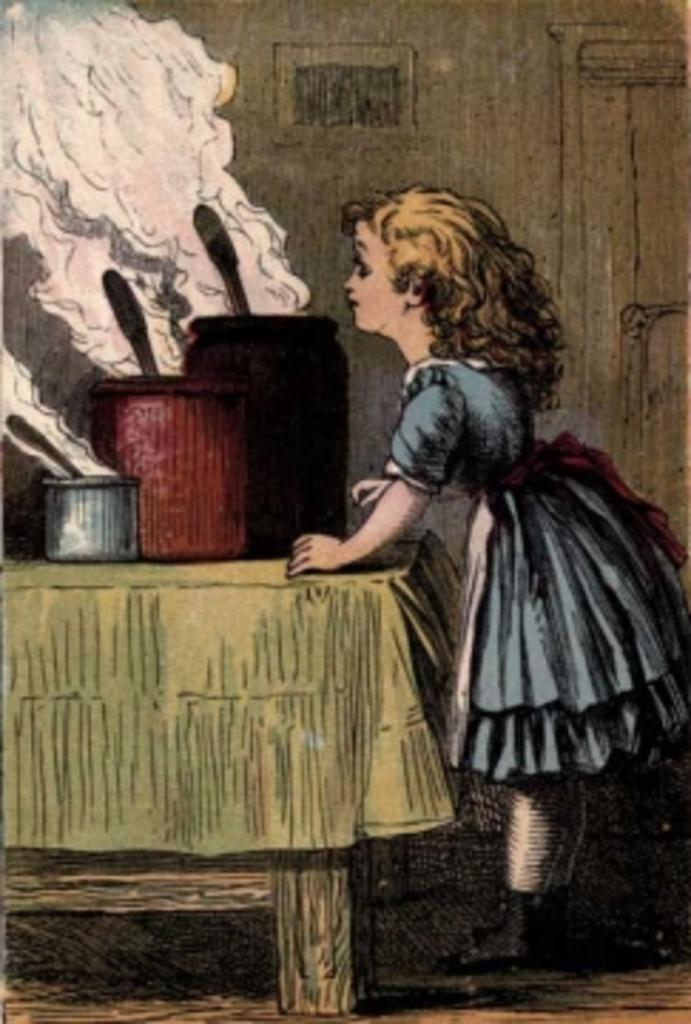What type of image is being described? The image contains animation. Can you describe the scene in the image? There is a girl standing beside a table. What is on the table in the image? There are objects on the table. How many sisters does the girl have in the image? There is no mention of sisters in the image, as it only features a girl standing beside a table. What type of event is taking place in the image? There is no indication of an event taking place in the image; it simply shows a girl standing beside a table with objects on it. 